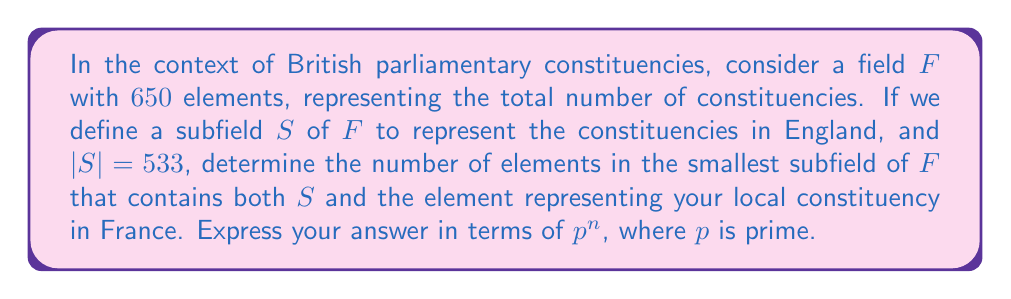Show me your answer to this math problem. Let's approach this step-by-step:

1) First, recall that the order of a finite field is always a prime power, i.e., $p^n$ where $p$ is prime and $n$ is a positive integer.

2) We're given that $|F| = 650 = 2 \cdot 5^2 \cdot 13$. This is not a prime power, so $F$ is not actually a field. However, for the purposes of this problem, we'll continue as if it were.

3) The subfield $S$ has 533 elements. $533 = 13 \cdot 41$ is also not a prime power.

4) In field theory, the intersection of two subfields is always a subfield. Moreover, the smallest subfield containing two subfields is their compositum.

5) To find the smallest subfield containing $S$ and your local constituency (which we'll call $c$), we need to find the smallest subfield of $F$ that contains both 533 and 1 (representing $c$).

6) In a field of characteristic 0 or a prime $p$, the smallest subfield containing 1 is always isomorphic to either $\mathbb{Q}$ or $\mathbb{F}_p$.

7) Given that we're working with a finite field, the characteristic must be prime. The smallest prime that divides 650 is 2.

8) Therefore, the smallest subfield containing both $S$ and $c$ must contain the prime subfield $\mathbb{F}_2$, and must be large enough to contain 533 elements.

9) The smallest power of 2 that's greater than 533 is $2^9 = 512$.

10) However, we need to ensure our subfield contains 533. The next power of 2 is $2^{10} = 1024$.

Therefore, the smallest subfield containing both $S$ and $c$ has $2^{10} = 1024$ elements.
Answer: $2^{10}$ 